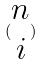<formula> <loc_0><loc_0><loc_500><loc_500>( \begin{matrix} n \\ i \end{matrix} )</formula> 